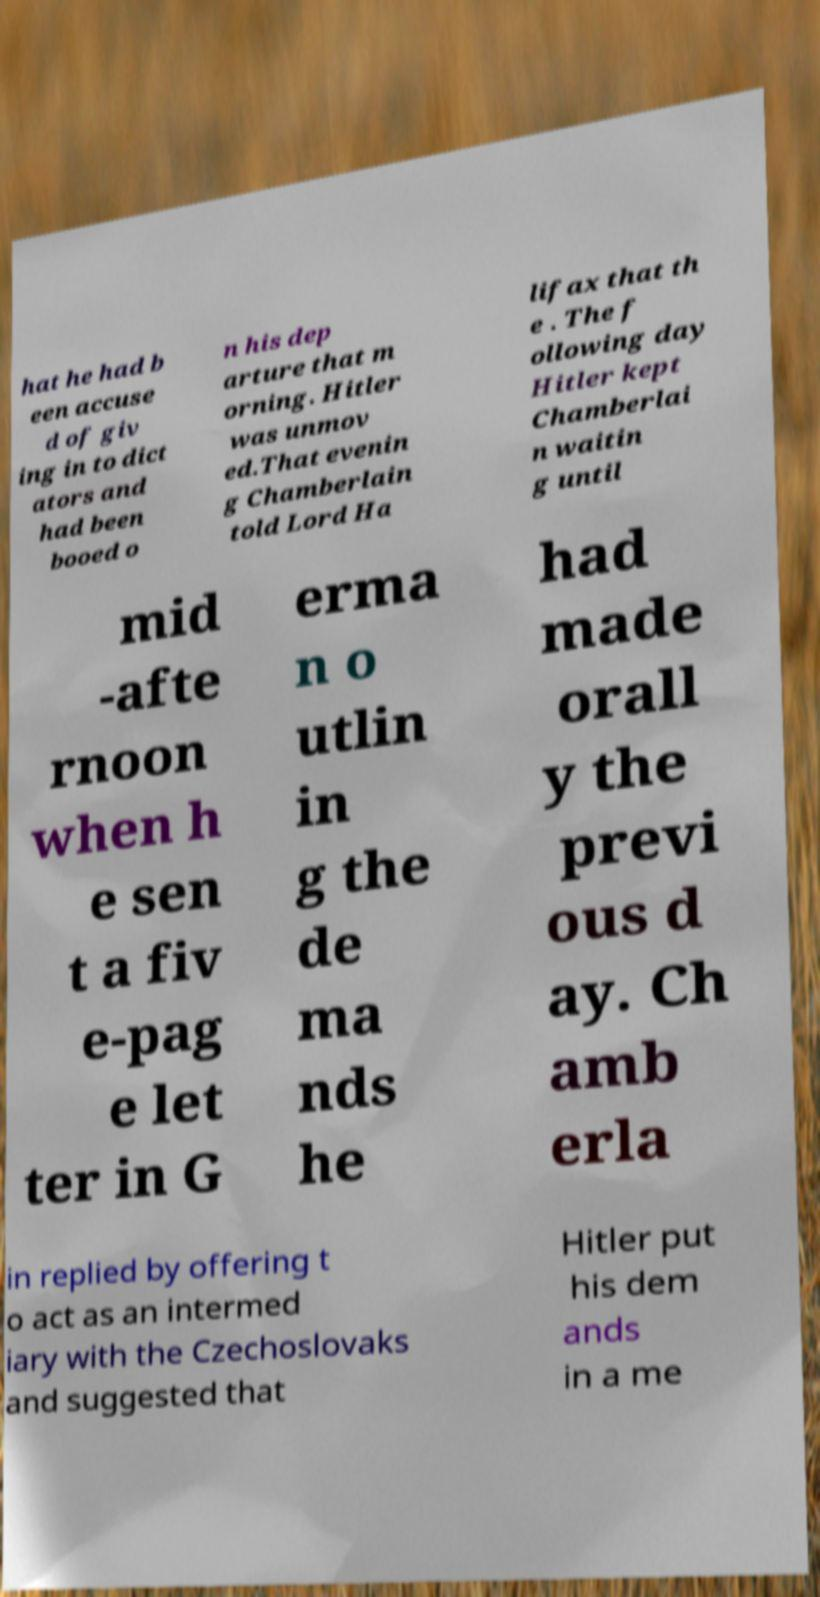Can you read and provide the text displayed in the image?This photo seems to have some interesting text. Can you extract and type it out for me? hat he had b een accuse d of giv ing in to dict ators and had been booed o n his dep arture that m orning. Hitler was unmov ed.That evenin g Chamberlain told Lord Ha lifax that th e . The f ollowing day Hitler kept Chamberlai n waitin g until mid -afte rnoon when h e sen t a fiv e-pag e let ter in G erma n o utlin in g the de ma nds he had made orall y the previ ous d ay. Ch amb erla in replied by offering t o act as an intermed iary with the Czechoslovaks and suggested that Hitler put his dem ands in a me 